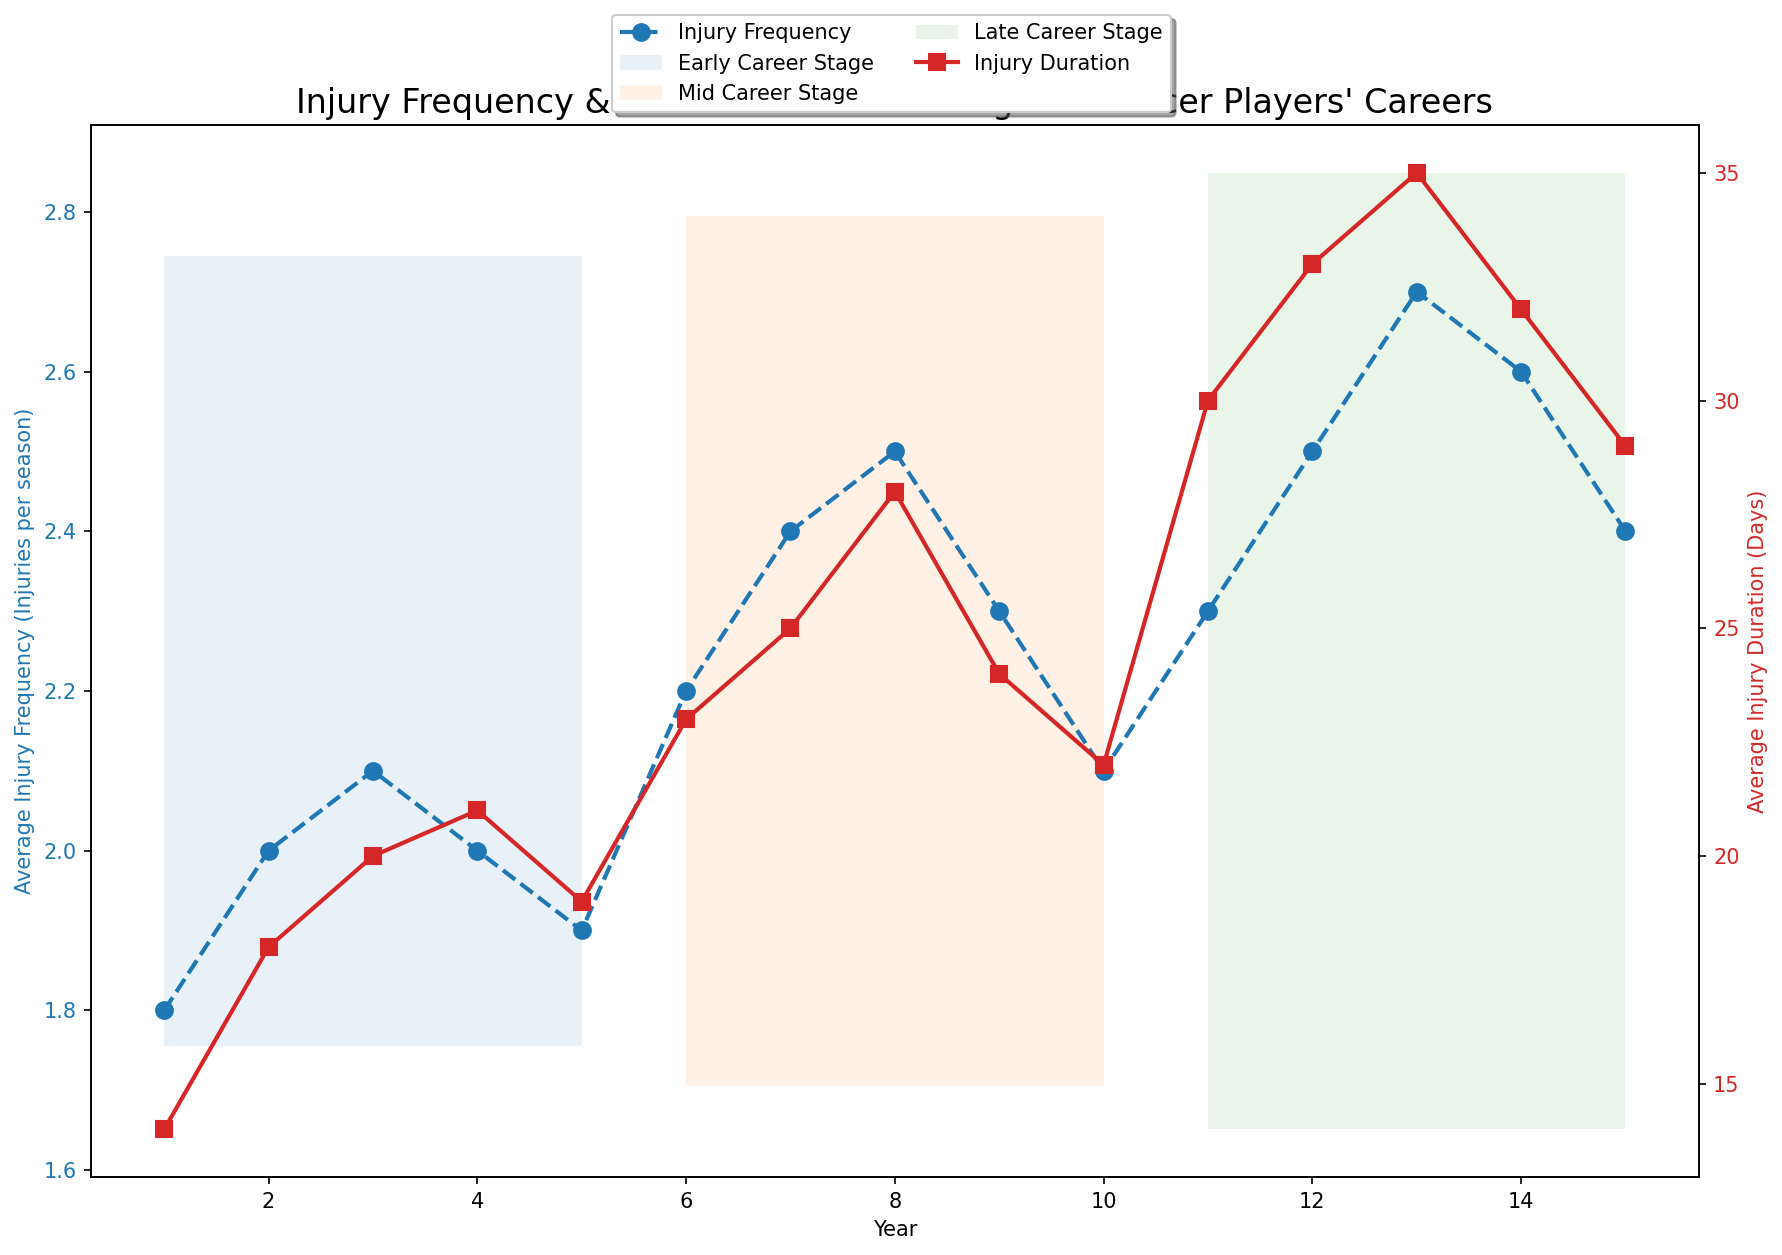What is the average injury frequency during the early career stage? To find the average injury frequency during the early career, sum the values for Average Injury Frequency during years 1 to 5 and divide by 5. (1.8 + 2.0 + 2.1 + 2.0 + 1.9) / 5 = 9.8 / 5 = 1.96
Answer: 1.96 How does the trend in injury duration from mid-career to late career look? Compare the injury duration from the mid-career (years 6 to 10) to late career (years 11 to 15). Mid-career values are 23, 25, 28, 24, 22, and late-career values are 30, 33, 35, 32, 29. The values generally increase from mid-career to late career.
Answer: Increases Which career stage has the highest average injury frequency? Compare the average injury frequencies in the early, mid, and late career stages by visually inspecting the lines. The late career stage (years 11 to 15) shows the highest frequency averaging around 2.5-2.7.
Answer: Late Career In which year is the injury duration the longest? Look at the red line representing injury duration. The peak duration appears in year 13 with the value of 35 days.
Answer: Year 13 What is the combined sum of injury durations during the mid-career stage? Summing values of injury duration from years 6 to 10: 23 + 25 + 28 + 24 + 22 = 122
Answer: 122 Is the increase in average injury frequency from early to mid-career larger than the increase from mid-career to late career? Calculate the increase. Early to mid-career: Avg early 1.96 -> Avg mid 2.3, increase: 2.3 - 1.96 = 0.34. Mid to late career: Avg mid 2.3 -> Avg late 2.5, increase: 2.5 - 2.3 = 0.2. The increase from early to mid-career is larger.
Answer: Yes By how many days did the average injury duration increase from year 10 to year 11? Injury duration in year 10 is 22 days and year 11 is 30 days. The increase is 30 - 22 = 8 days.
Answer: 8 days What is the overall trend of injury frequency across the career stages? Inspect the blue line representing injury frequency across early, mid, and late career stages. It generally increases from early to mid to late career.
Answer: Generally increases Which year has the minimum injury frequency and what is its value? Find the lowest point on the blue line. Year 1 has the minimum frequency with a value of 1.8.
Answer: Year 1, 1.8 